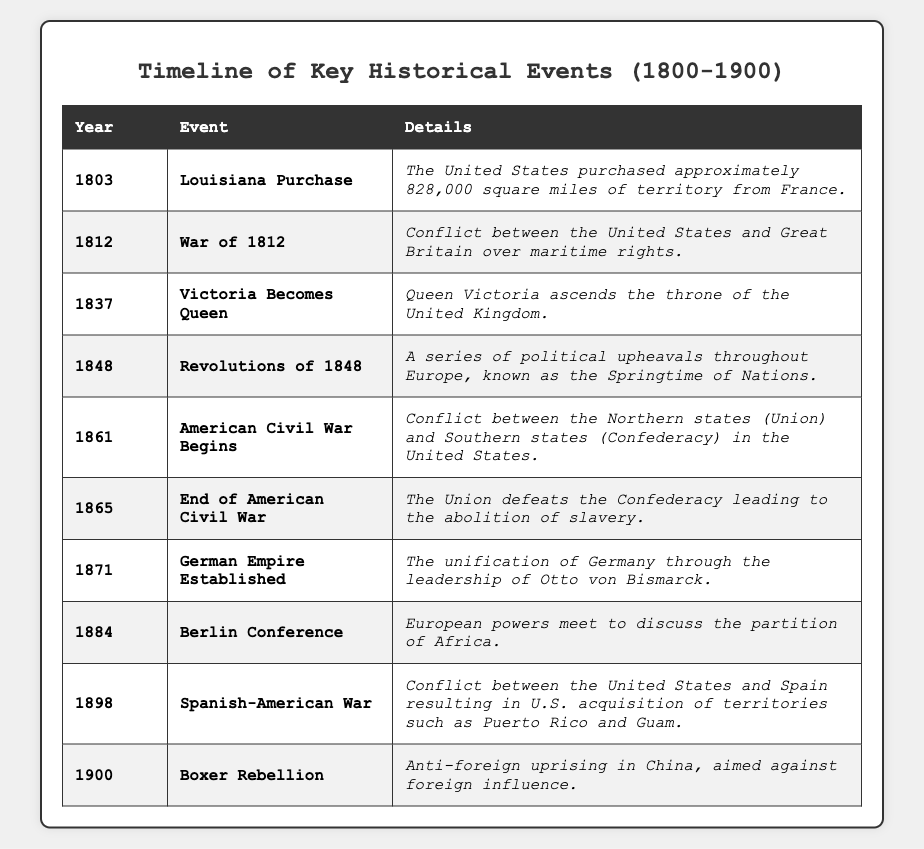What event occurred in 1865? By referring to the table, we can locate the row for the year 1865 and see the corresponding event listed, which is the "End of American Civil War."
Answer: End of American Civil War What year did the Berlin Conference take place? Looking at the table, the Berlin Conference is listed under the year 1884.
Answer: 1884 Which event led to the abolition of slavery? The table states that the "End of American Civil War" in 1865 led to the abolition of slavery.
Answer: End of American Civil War How many years passed between the Louisiana Purchase and the War of 1812? The Louisiana Purchase occurred in 1803 and the War of 1812 in 1812. Thus, 1812 - 1803 = 9 years elapsed between these events.
Answer: 9 years Which historical event marks the beginning of the American Civil War? The table indicates that the "American Civil War Begins" is the event that marks its start, which is listed in 1861.
Answer: American Civil War Begins Was Queen Victoria's ascension to the throne in 1837 during the 19th century? Yes, 1837 falls within the 19th century, which spans from 1801 to 1900.
Answer: Yes Which event occurred after the Revolutions of 1848? The table shows that the event "American Civil War Begins" took place in 1861, following the Revolutions of 1848, which occurred in the same decade.
Answer: American Civil War Begins What was the outcome of the Spanish-American War in 1898? According to the table, the Spanish-American War resulted in the U.S. acquiring territories, specifically mentioning Puerto Rico and Guam.
Answer: U.S. acquisition of territories Which event involved the unification of Germany? The table lists the "German Empire Established" event in 1871, which describes the unification of Germany.
Answer: German Empire Established Are the Revolutions of 1848 and the end of the American Civil War in the same decade? No, the Revolutions of 1848 occurred in the 1840s, while the American Civil War ended in 1865, which is in the 1860s.
Answer: No What were the implications of the Berlin Conference? The table notes that during the Berlin Conference in 1884, European powers met to discuss the partition of Africa, indicating significant colonial implications.
Answer: Colonial implications in Africa 